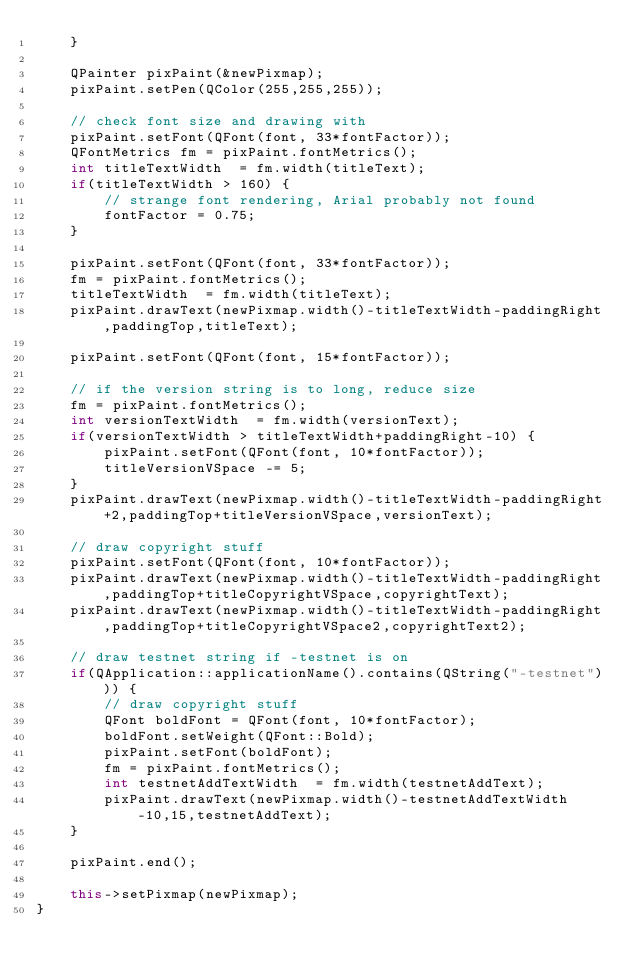Convert code to text. <code><loc_0><loc_0><loc_500><loc_500><_C++_>    }

    QPainter pixPaint(&newPixmap);
    pixPaint.setPen(QColor(255,255,255));

    // check font size and drawing with
    pixPaint.setFont(QFont(font, 33*fontFactor));
    QFontMetrics fm = pixPaint.fontMetrics();
    int titleTextWidth  = fm.width(titleText);
    if(titleTextWidth > 160) {
        // strange font rendering, Arial probably not found
        fontFactor = 0.75;
    }

    pixPaint.setFont(QFont(font, 33*fontFactor));
    fm = pixPaint.fontMetrics();
    titleTextWidth  = fm.width(titleText);
    pixPaint.drawText(newPixmap.width()-titleTextWidth-paddingRight,paddingTop,titleText);

    pixPaint.setFont(QFont(font, 15*fontFactor));

    // if the version string is to long, reduce size
    fm = pixPaint.fontMetrics();
    int versionTextWidth  = fm.width(versionText);
    if(versionTextWidth > titleTextWidth+paddingRight-10) {
        pixPaint.setFont(QFont(font, 10*fontFactor));
        titleVersionVSpace -= 5;
    }
    pixPaint.drawText(newPixmap.width()-titleTextWidth-paddingRight+2,paddingTop+titleVersionVSpace,versionText);

    // draw copyright stuff
    pixPaint.setFont(QFont(font, 10*fontFactor));
    pixPaint.drawText(newPixmap.width()-titleTextWidth-paddingRight,paddingTop+titleCopyrightVSpace,copyrightText);
    pixPaint.drawText(newPixmap.width()-titleTextWidth-paddingRight,paddingTop+titleCopyrightVSpace2,copyrightText2);

    // draw testnet string if -testnet is on
    if(QApplication::applicationName().contains(QString("-testnet"))) {
        // draw copyright stuff
        QFont boldFont = QFont(font, 10*fontFactor);
        boldFont.setWeight(QFont::Bold);
        pixPaint.setFont(boldFont);
        fm = pixPaint.fontMetrics();
        int testnetAddTextWidth  = fm.width(testnetAddText);
        pixPaint.drawText(newPixmap.width()-testnetAddTextWidth-10,15,testnetAddText);
    }

    pixPaint.end();

    this->setPixmap(newPixmap);
}
</code> 